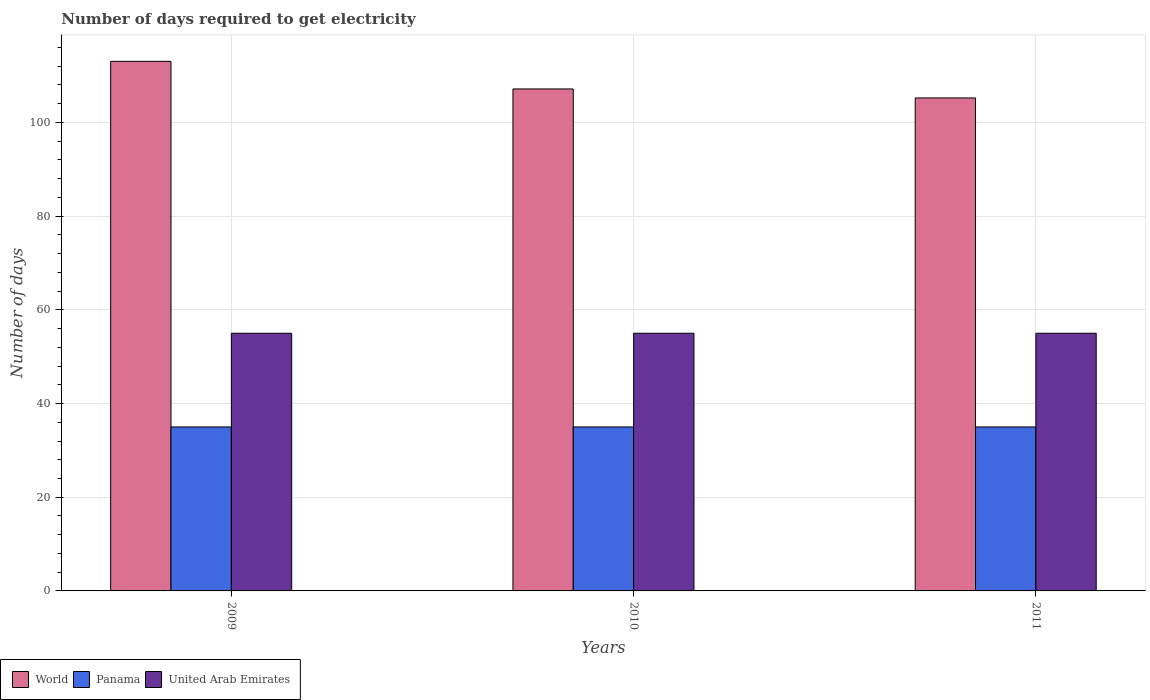How many different coloured bars are there?
Provide a short and direct response. 3. Are the number of bars per tick equal to the number of legend labels?
Give a very brief answer. Yes. How many bars are there on the 1st tick from the left?
Offer a terse response. 3. What is the number of days required to get electricity in in Panama in 2009?
Keep it short and to the point. 35. Across all years, what is the maximum number of days required to get electricity in in World?
Make the answer very short. 113.03. Across all years, what is the minimum number of days required to get electricity in in Panama?
Your response must be concise. 35. What is the total number of days required to get electricity in in United Arab Emirates in the graph?
Keep it short and to the point. 165. What is the difference between the number of days required to get electricity in in United Arab Emirates in 2009 and that in 2010?
Give a very brief answer. 0. What is the difference between the number of days required to get electricity in in Panama in 2011 and the number of days required to get electricity in in United Arab Emirates in 2010?
Your answer should be compact. -20. In the year 2009, what is the difference between the number of days required to get electricity in in United Arab Emirates and number of days required to get electricity in in World?
Your answer should be compact. -58.03. What is the ratio of the number of days required to get electricity in in World in 2009 to that in 2010?
Offer a terse response. 1.05. What is the difference between the highest and the second highest number of days required to get electricity in in World?
Keep it short and to the point. 5.89. In how many years, is the number of days required to get electricity in in United Arab Emirates greater than the average number of days required to get electricity in in United Arab Emirates taken over all years?
Provide a succinct answer. 0. What does the 3rd bar from the left in 2009 represents?
Your response must be concise. United Arab Emirates. What does the 3rd bar from the right in 2009 represents?
Offer a terse response. World. Is it the case that in every year, the sum of the number of days required to get electricity in in Panama and number of days required to get electricity in in United Arab Emirates is greater than the number of days required to get electricity in in World?
Provide a short and direct response. No. How many years are there in the graph?
Your answer should be compact. 3. Are the values on the major ticks of Y-axis written in scientific E-notation?
Make the answer very short. No. How many legend labels are there?
Provide a short and direct response. 3. What is the title of the graph?
Provide a short and direct response. Number of days required to get electricity. Does "Europe(developing only)" appear as one of the legend labels in the graph?
Provide a short and direct response. No. What is the label or title of the Y-axis?
Offer a very short reply. Number of days. What is the Number of days in World in 2009?
Your response must be concise. 113.03. What is the Number of days of Panama in 2009?
Provide a succinct answer. 35. What is the Number of days in World in 2010?
Offer a very short reply. 107.15. What is the Number of days of Panama in 2010?
Provide a short and direct response. 35. What is the Number of days of United Arab Emirates in 2010?
Keep it short and to the point. 55. What is the Number of days in World in 2011?
Offer a terse response. 105.22. Across all years, what is the maximum Number of days in World?
Ensure brevity in your answer.  113.03. Across all years, what is the maximum Number of days of Panama?
Provide a succinct answer. 35. Across all years, what is the maximum Number of days of United Arab Emirates?
Give a very brief answer. 55. Across all years, what is the minimum Number of days in World?
Your answer should be compact. 105.22. Across all years, what is the minimum Number of days of Panama?
Your answer should be compact. 35. What is the total Number of days of World in the graph?
Give a very brief answer. 325.4. What is the total Number of days in Panama in the graph?
Provide a succinct answer. 105. What is the total Number of days of United Arab Emirates in the graph?
Make the answer very short. 165. What is the difference between the Number of days in World in 2009 and that in 2010?
Make the answer very short. 5.89. What is the difference between the Number of days of Panama in 2009 and that in 2010?
Your answer should be very brief. 0. What is the difference between the Number of days in World in 2009 and that in 2011?
Your answer should be very brief. 7.81. What is the difference between the Number of days in World in 2010 and that in 2011?
Your response must be concise. 1.92. What is the difference between the Number of days in United Arab Emirates in 2010 and that in 2011?
Offer a terse response. 0. What is the difference between the Number of days of World in 2009 and the Number of days of Panama in 2010?
Make the answer very short. 78.03. What is the difference between the Number of days of World in 2009 and the Number of days of United Arab Emirates in 2010?
Make the answer very short. 58.03. What is the difference between the Number of days of Panama in 2009 and the Number of days of United Arab Emirates in 2010?
Provide a succinct answer. -20. What is the difference between the Number of days in World in 2009 and the Number of days in Panama in 2011?
Provide a succinct answer. 78.03. What is the difference between the Number of days of World in 2009 and the Number of days of United Arab Emirates in 2011?
Provide a short and direct response. 58.03. What is the difference between the Number of days in Panama in 2009 and the Number of days in United Arab Emirates in 2011?
Keep it short and to the point. -20. What is the difference between the Number of days of World in 2010 and the Number of days of Panama in 2011?
Offer a terse response. 72.15. What is the difference between the Number of days of World in 2010 and the Number of days of United Arab Emirates in 2011?
Your answer should be compact. 52.15. What is the average Number of days of World per year?
Your answer should be compact. 108.47. What is the average Number of days in Panama per year?
Make the answer very short. 35. In the year 2009, what is the difference between the Number of days of World and Number of days of Panama?
Offer a terse response. 78.03. In the year 2009, what is the difference between the Number of days of World and Number of days of United Arab Emirates?
Offer a terse response. 58.03. In the year 2009, what is the difference between the Number of days of Panama and Number of days of United Arab Emirates?
Give a very brief answer. -20. In the year 2010, what is the difference between the Number of days of World and Number of days of Panama?
Provide a succinct answer. 72.15. In the year 2010, what is the difference between the Number of days of World and Number of days of United Arab Emirates?
Your response must be concise. 52.15. In the year 2011, what is the difference between the Number of days of World and Number of days of Panama?
Provide a short and direct response. 70.22. In the year 2011, what is the difference between the Number of days of World and Number of days of United Arab Emirates?
Ensure brevity in your answer.  50.22. In the year 2011, what is the difference between the Number of days in Panama and Number of days in United Arab Emirates?
Offer a very short reply. -20. What is the ratio of the Number of days of World in 2009 to that in 2010?
Your answer should be very brief. 1.05. What is the ratio of the Number of days of Panama in 2009 to that in 2010?
Make the answer very short. 1. What is the ratio of the Number of days of World in 2009 to that in 2011?
Provide a short and direct response. 1.07. What is the ratio of the Number of days in United Arab Emirates in 2009 to that in 2011?
Give a very brief answer. 1. What is the ratio of the Number of days in World in 2010 to that in 2011?
Keep it short and to the point. 1.02. What is the ratio of the Number of days of Panama in 2010 to that in 2011?
Provide a short and direct response. 1. What is the difference between the highest and the second highest Number of days in World?
Ensure brevity in your answer.  5.89. What is the difference between the highest and the second highest Number of days in Panama?
Ensure brevity in your answer.  0. What is the difference between the highest and the second highest Number of days in United Arab Emirates?
Offer a very short reply. 0. What is the difference between the highest and the lowest Number of days in World?
Ensure brevity in your answer.  7.81. 